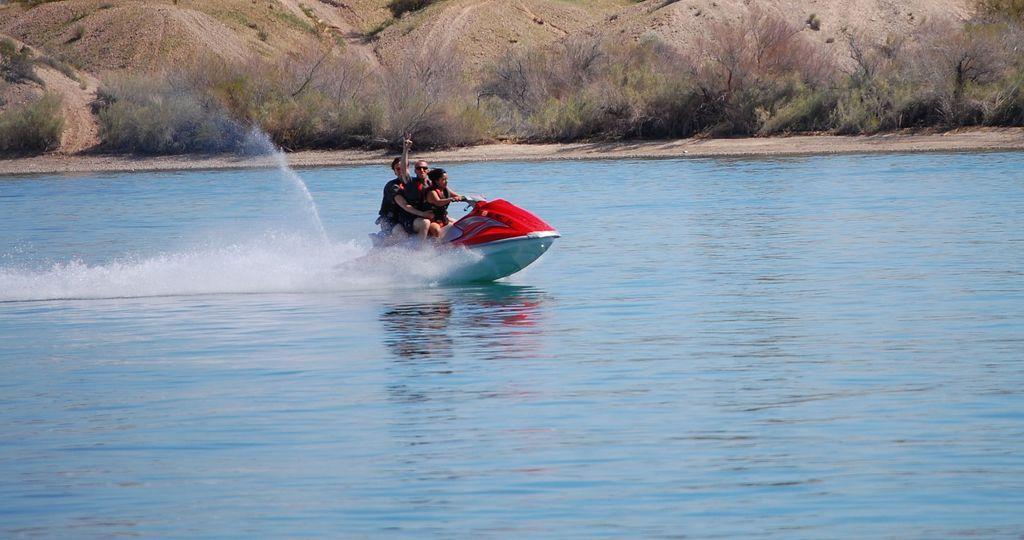Describe this image in one or two sentences. In this picture we can see three people sitting in a speed boat, at the bottom there is water, we can see grass here. 